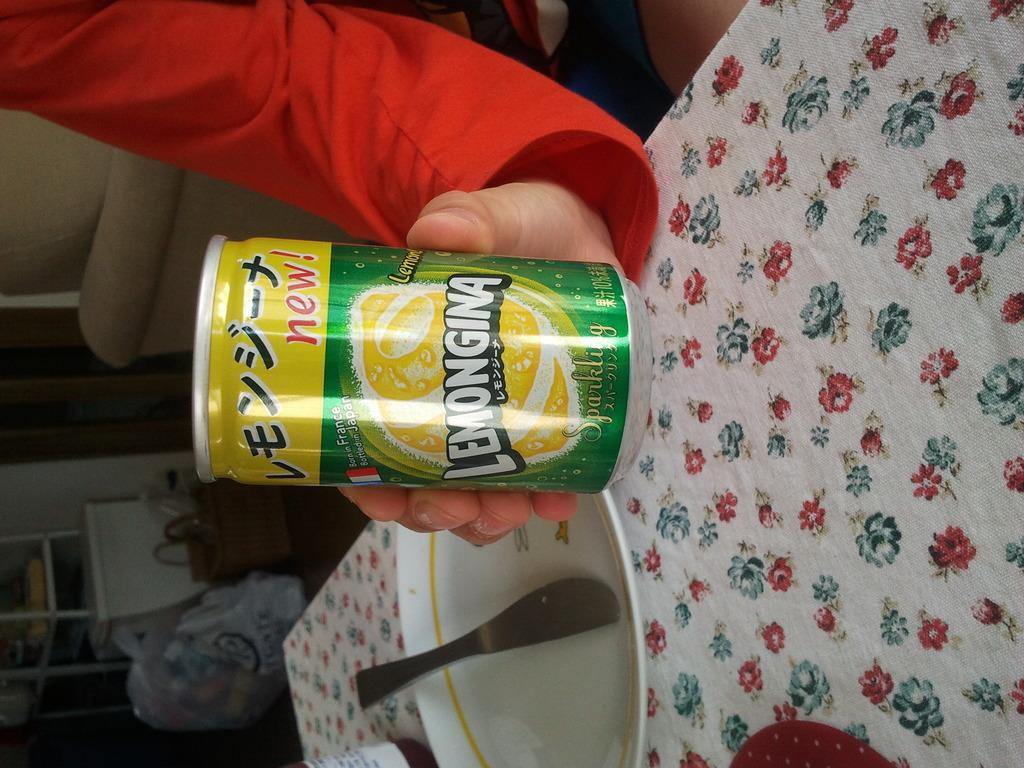<image>
Create a compact narrative representing the image presented. a can that has the word lemon on it 